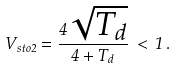Convert formula to latex. <formula><loc_0><loc_0><loc_500><loc_500>V _ { s t o 2 } = \frac { 4 \sqrt { T _ { d } } } { 4 + T _ { d } } \, < \, 1 \, .</formula> 